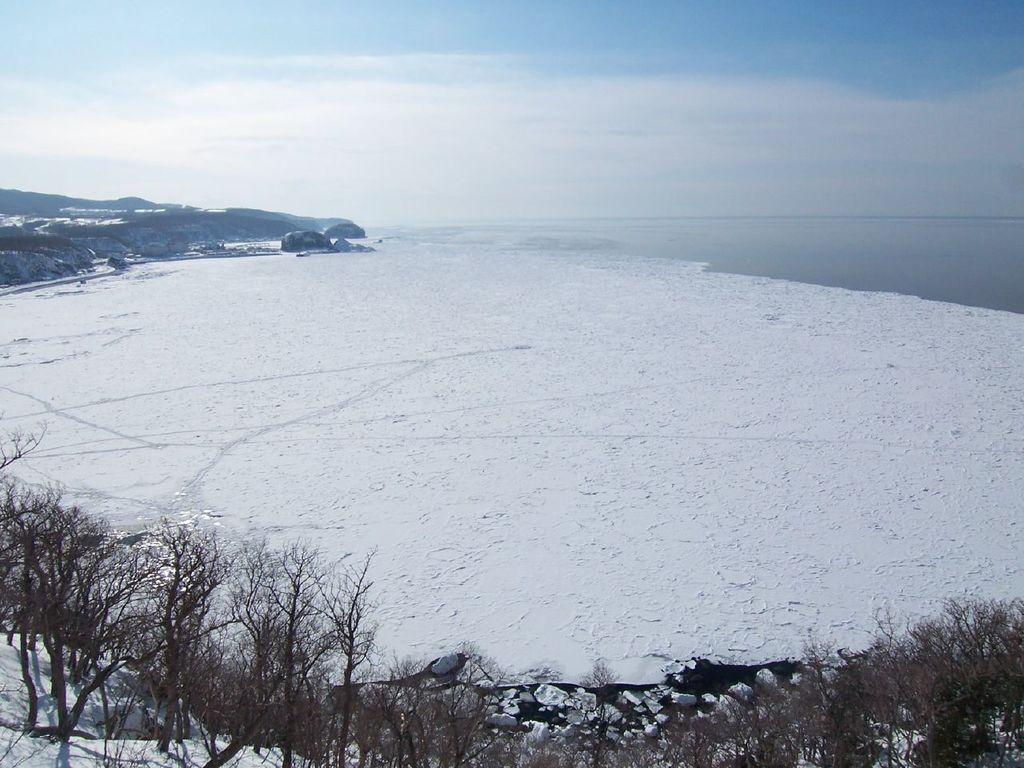How would you summarize this image in a sentence or two? In this image, I can see hills, trees and the snow. On the right side of the image, there is water. In the background, there is the sky. 